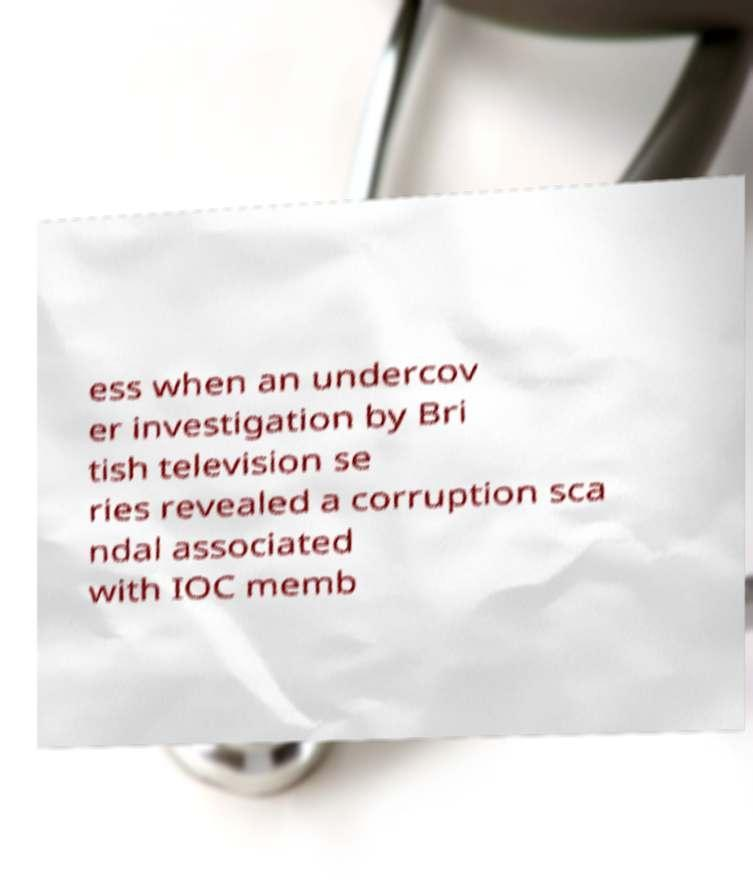What messages or text are displayed in this image? I need them in a readable, typed format. ess when an undercov er investigation by Bri tish television se ries revealed a corruption sca ndal associated with IOC memb 